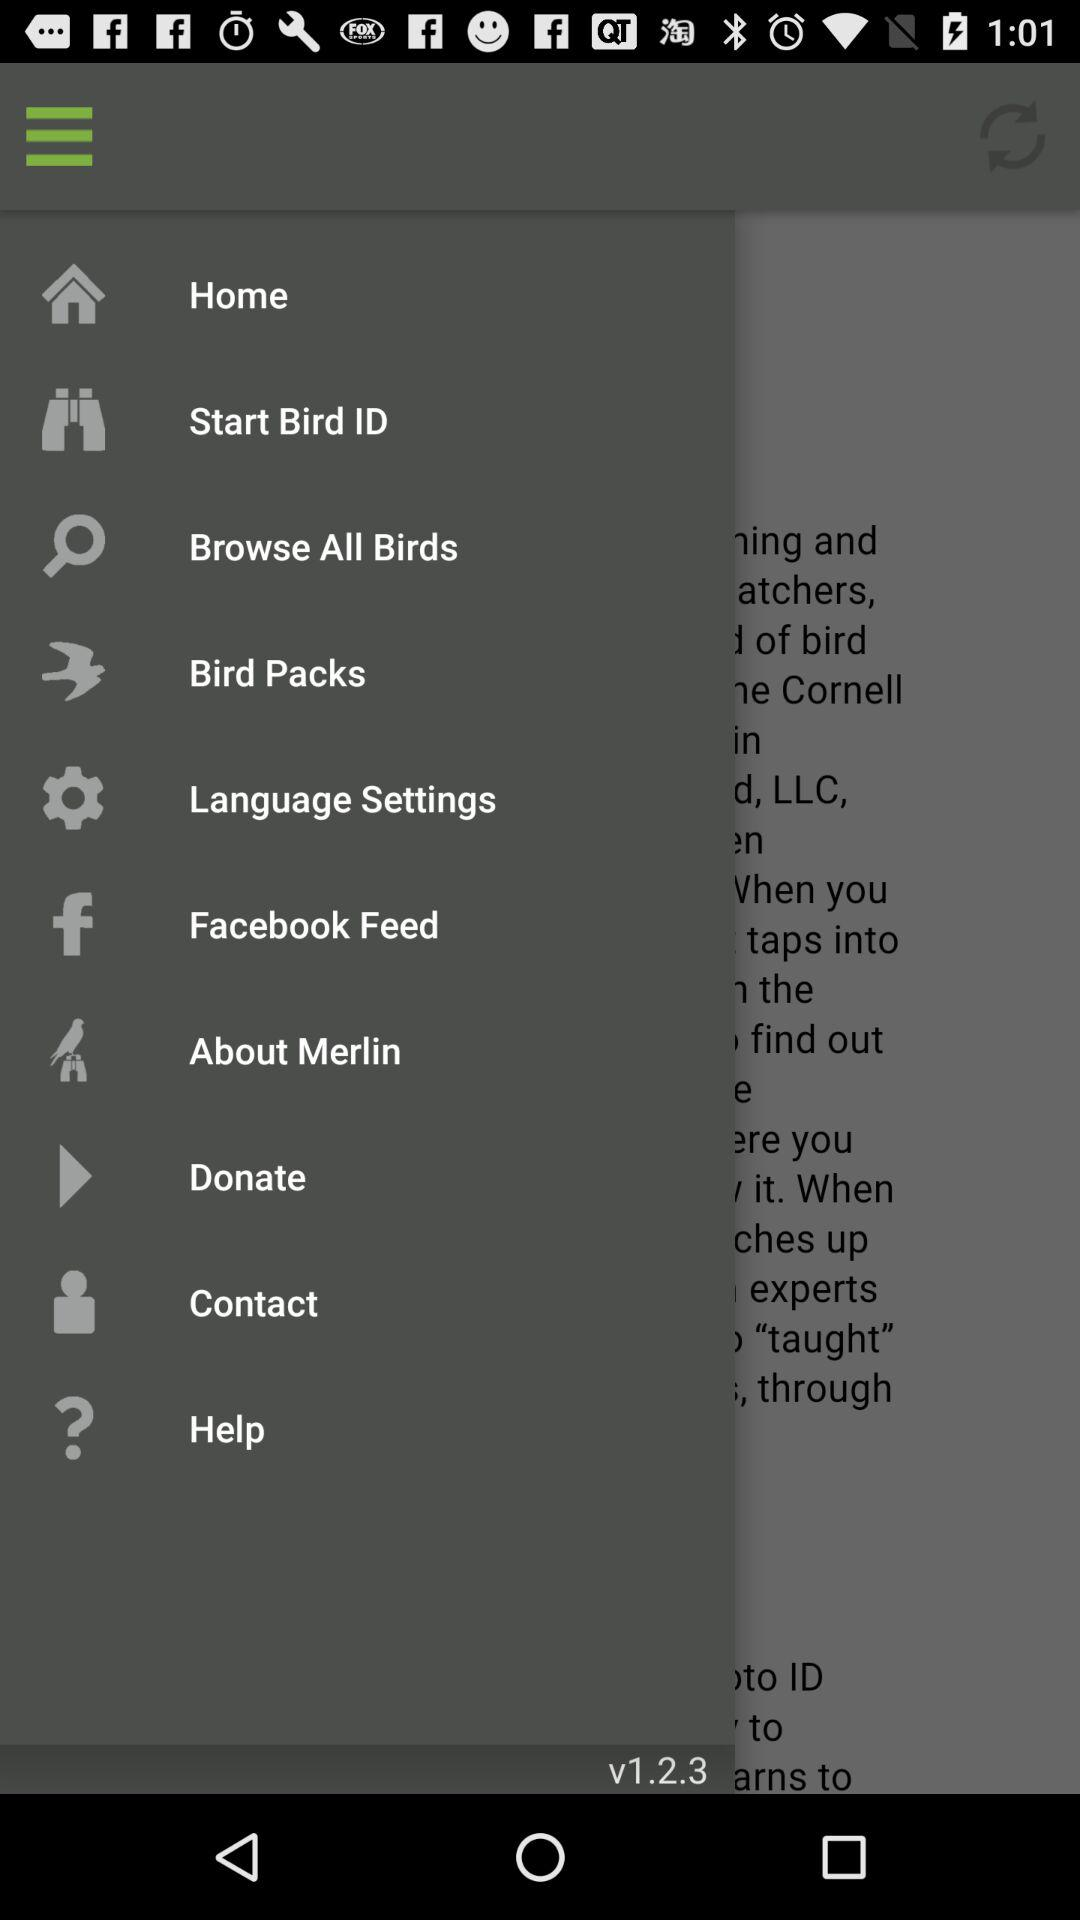What is the version? The version is v1.2.3. 